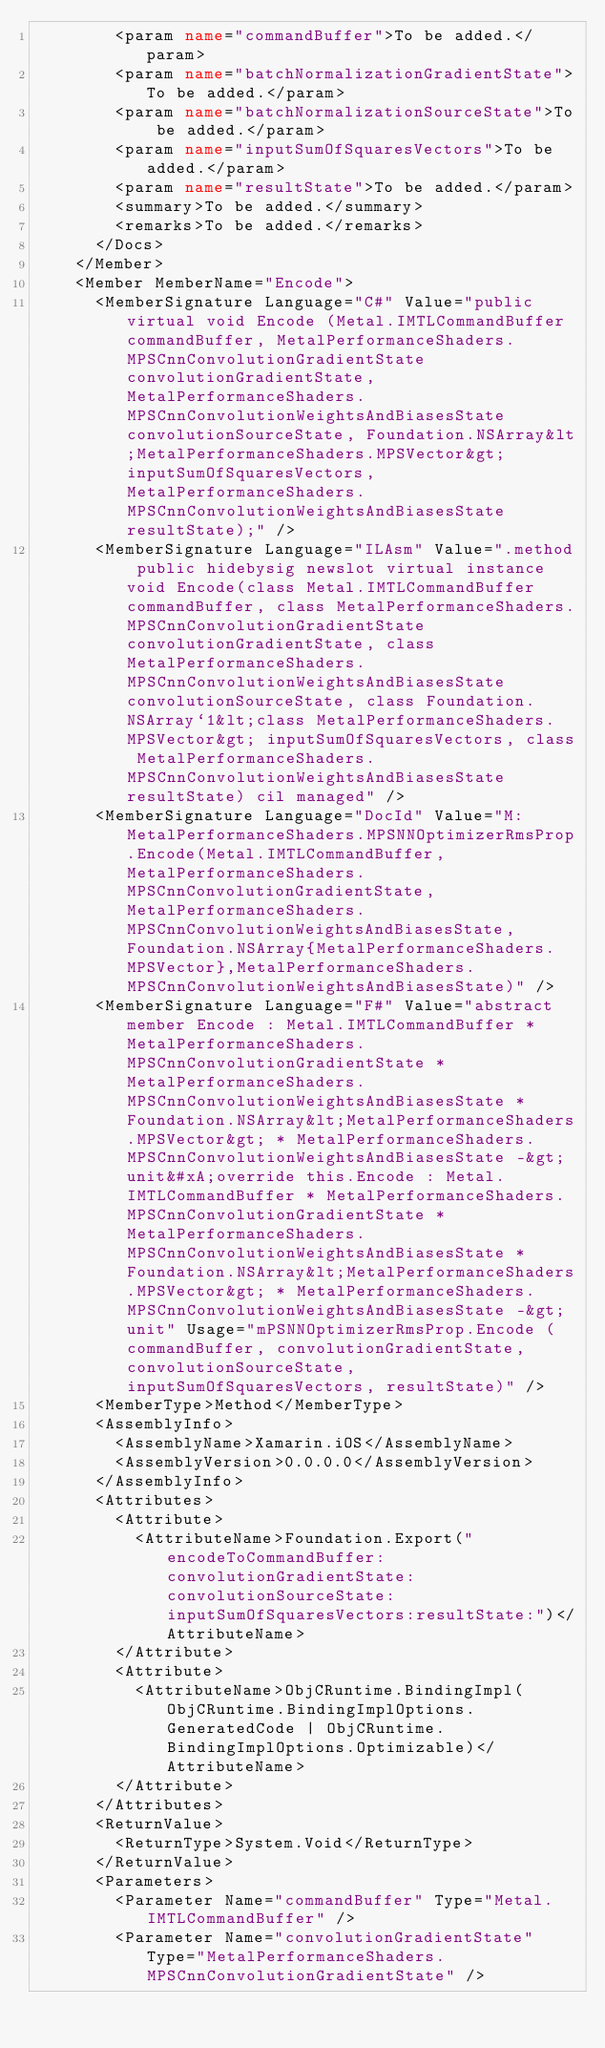<code> <loc_0><loc_0><loc_500><loc_500><_XML_>        <param name="commandBuffer">To be added.</param>
        <param name="batchNormalizationGradientState">To be added.</param>
        <param name="batchNormalizationSourceState">To be added.</param>
        <param name="inputSumOfSquaresVectors">To be added.</param>
        <param name="resultState">To be added.</param>
        <summary>To be added.</summary>
        <remarks>To be added.</remarks>
      </Docs>
    </Member>
    <Member MemberName="Encode">
      <MemberSignature Language="C#" Value="public virtual void Encode (Metal.IMTLCommandBuffer commandBuffer, MetalPerformanceShaders.MPSCnnConvolutionGradientState convolutionGradientState, MetalPerformanceShaders.MPSCnnConvolutionWeightsAndBiasesState convolutionSourceState, Foundation.NSArray&lt;MetalPerformanceShaders.MPSVector&gt; inputSumOfSquaresVectors, MetalPerformanceShaders.MPSCnnConvolutionWeightsAndBiasesState resultState);" />
      <MemberSignature Language="ILAsm" Value=".method public hidebysig newslot virtual instance void Encode(class Metal.IMTLCommandBuffer commandBuffer, class MetalPerformanceShaders.MPSCnnConvolutionGradientState convolutionGradientState, class MetalPerformanceShaders.MPSCnnConvolutionWeightsAndBiasesState convolutionSourceState, class Foundation.NSArray`1&lt;class MetalPerformanceShaders.MPSVector&gt; inputSumOfSquaresVectors, class MetalPerformanceShaders.MPSCnnConvolutionWeightsAndBiasesState resultState) cil managed" />
      <MemberSignature Language="DocId" Value="M:MetalPerformanceShaders.MPSNNOptimizerRmsProp.Encode(Metal.IMTLCommandBuffer,MetalPerformanceShaders.MPSCnnConvolutionGradientState,MetalPerformanceShaders.MPSCnnConvolutionWeightsAndBiasesState,Foundation.NSArray{MetalPerformanceShaders.MPSVector},MetalPerformanceShaders.MPSCnnConvolutionWeightsAndBiasesState)" />
      <MemberSignature Language="F#" Value="abstract member Encode : Metal.IMTLCommandBuffer * MetalPerformanceShaders.MPSCnnConvolutionGradientState * MetalPerformanceShaders.MPSCnnConvolutionWeightsAndBiasesState * Foundation.NSArray&lt;MetalPerformanceShaders.MPSVector&gt; * MetalPerformanceShaders.MPSCnnConvolutionWeightsAndBiasesState -&gt; unit&#xA;override this.Encode : Metal.IMTLCommandBuffer * MetalPerformanceShaders.MPSCnnConvolutionGradientState * MetalPerformanceShaders.MPSCnnConvolutionWeightsAndBiasesState * Foundation.NSArray&lt;MetalPerformanceShaders.MPSVector&gt; * MetalPerformanceShaders.MPSCnnConvolutionWeightsAndBiasesState -&gt; unit" Usage="mPSNNOptimizerRmsProp.Encode (commandBuffer, convolutionGradientState, convolutionSourceState, inputSumOfSquaresVectors, resultState)" />
      <MemberType>Method</MemberType>
      <AssemblyInfo>
        <AssemblyName>Xamarin.iOS</AssemblyName>
        <AssemblyVersion>0.0.0.0</AssemblyVersion>
      </AssemblyInfo>
      <Attributes>
        <Attribute>
          <AttributeName>Foundation.Export("encodeToCommandBuffer:convolutionGradientState:convolutionSourceState:inputSumOfSquaresVectors:resultState:")</AttributeName>
        </Attribute>
        <Attribute>
          <AttributeName>ObjCRuntime.BindingImpl(ObjCRuntime.BindingImplOptions.GeneratedCode | ObjCRuntime.BindingImplOptions.Optimizable)</AttributeName>
        </Attribute>
      </Attributes>
      <ReturnValue>
        <ReturnType>System.Void</ReturnType>
      </ReturnValue>
      <Parameters>
        <Parameter Name="commandBuffer" Type="Metal.IMTLCommandBuffer" />
        <Parameter Name="convolutionGradientState" Type="MetalPerformanceShaders.MPSCnnConvolutionGradientState" /></code> 